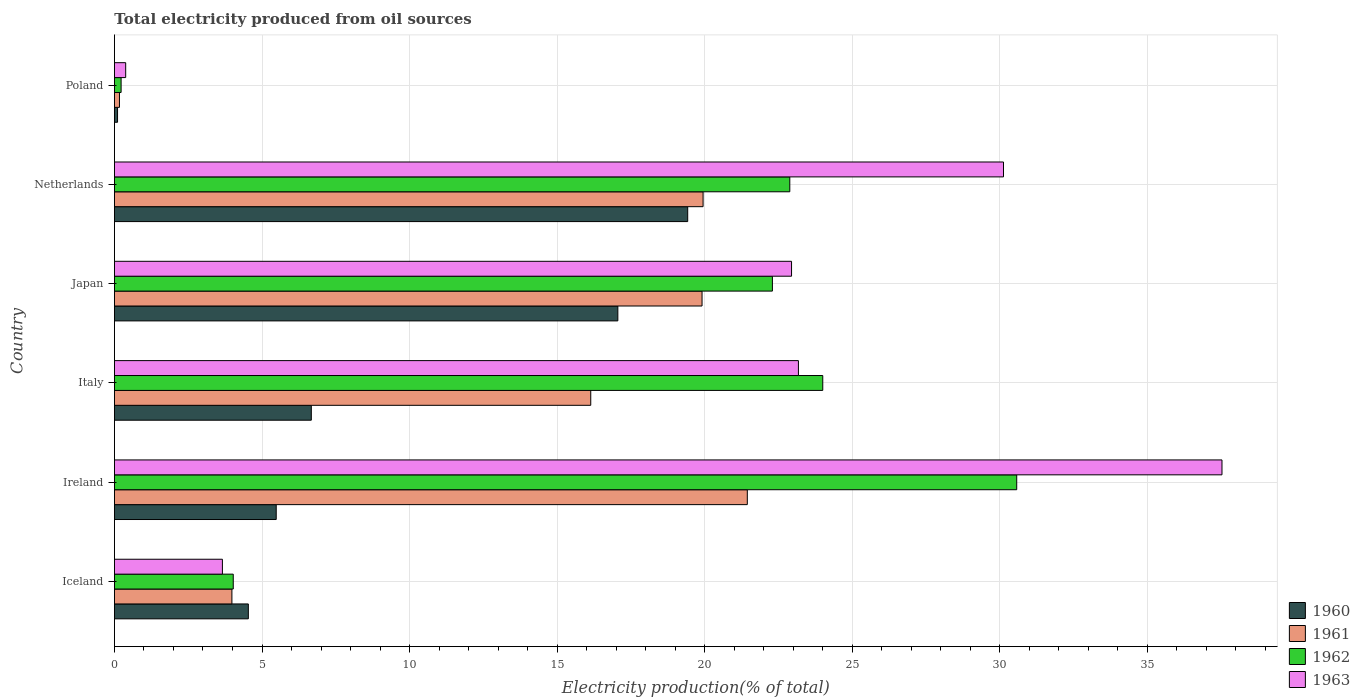How many different coloured bars are there?
Your answer should be very brief. 4. How many groups of bars are there?
Your answer should be very brief. 6. Are the number of bars per tick equal to the number of legend labels?
Your answer should be compact. Yes. Are the number of bars on each tick of the Y-axis equal?
Provide a succinct answer. Yes. How many bars are there on the 3rd tick from the bottom?
Give a very brief answer. 4. What is the total electricity produced in 1962 in Italy?
Your answer should be very brief. 24. Across all countries, what is the maximum total electricity produced in 1963?
Provide a succinct answer. 37.53. Across all countries, what is the minimum total electricity produced in 1960?
Make the answer very short. 0.11. What is the total total electricity produced in 1960 in the graph?
Offer a very short reply. 53.28. What is the difference between the total electricity produced in 1962 in Japan and that in Netherlands?
Your response must be concise. -0.59. What is the difference between the total electricity produced in 1962 in Italy and the total electricity produced in 1963 in Netherlands?
Make the answer very short. -6.12. What is the average total electricity produced in 1963 per country?
Provide a short and direct response. 19.63. What is the difference between the total electricity produced in 1962 and total electricity produced in 1960 in Japan?
Ensure brevity in your answer.  5.24. In how many countries, is the total electricity produced in 1961 greater than 18 %?
Offer a very short reply. 3. What is the ratio of the total electricity produced in 1963 in Netherlands to that in Poland?
Give a very brief answer. 78.92. Is the total electricity produced in 1962 in Iceland less than that in Netherlands?
Your answer should be very brief. Yes. What is the difference between the highest and the second highest total electricity produced in 1961?
Provide a short and direct response. 1.5. What is the difference between the highest and the lowest total electricity produced in 1961?
Provide a short and direct response. 21.27. In how many countries, is the total electricity produced in 1962 greater than the average total electricity produced in 1962 taken over all countries?
Your answer should be very brief. 4. Is it the case that in every country, the sum of the total electricity produced in 1962 and total electricity produced in 1963 is greater than the sum of total electricity produced in 1961 and total electricity produced in 1960?
Provide a succinct answer. No. Are all the bars in the graph horizontal?
Make the answer very short. Yes. How many countries are there in the graph?
Your response must be concise. 6. What is the difference between two consecutive major ticks on the X-axis?
Offer a terse response. 5. Where does the legend appear in the graph?
Ensure brevity in your answer.  Bottom right. What is the title of the graph?
Keep it short and to the point. Total electricity produced from oil sources. Does "1977" appear as one of the legend labels in the graph?
Your answer should be very brief. No. What is the Electricity production(% of total) in 1960 in Iceland?
Provide a short and direct response. 4.54. What is the Electricity production(% of total) in 1961 in Iceland?
Make the answer very short. 3.98. What is the Electricity production(% of total) of 1962 in Iceland?
Ensure brevity in your answer.  4.03. What is the Electricity production(% of total) of 1963 in Iceland?
Your answer should be compact. 3.66. What is the Electricity production(% of total) in 1960 in Ireland?
Provide a short and direct response. 5.48. What is the Electricity production(% of total) in 1961 in Ireland?
Your response must be concise. 21.44. What is the Electricity production(% of total) of 1962 in Ireland?
Make the answer very short. 30.57. What is the Electricity production(% of total) in 1963 in Ireland?
Offer a very short reply. 37.53. What is the Electricity production(% of total) of 1960 in Italy?
Keep it short and to the point. 6.67. What is the Electricity production(% of total) of 1961 in Italy?
Offer a very short reply. 16.14. What is the Electricity production(% of total) of 1962 in Italy?
Ensure brevity in your answer.  24. What is the Electricity production(% of total) in 1963 in Italy?
Keep it short and to the point. 23.17. What is the Electricity production(% of total) of 1960 in Japan?
Your answer should be compact. 17.06. What is the Electricity production(% of total) of 1961 in Japan?
Your answer should be compact. 19.91. What is the Electricity production(% of total) of 1962 in Japan?
Provide a short and direct response. 22.29. What is the Electricity production(% of total) of 1963 in Japan?
Your response must be concise. 22.94. What is the Electricity production(% of total) in 1960 in Netherlands?
Provide a short and direct response. 19.42. What is the Electricity production(% of total) of 1961 in Netherlands?
Offer a terse response. 19.94. What is the Electricity production(% of total) in 1962 in Netherlands?
Your answer should be compact. 22.88. What is the Electricity production(% of total) of 1963 in Netherlands?
Give a very brief answer. 30.12. What is the Electricity production(% of total) in 1960 in Poland?
Offer a very short reply. 0.11. What is the Electricity production(% of total) of 1961 in Poland?
Offer a very short reply. 0.17. What is the Electricity production(% of total) of 1962 in Poland?
Provide a succinct answer. 0.23. What is the Electricity production(% of total) in 1963 in Poland?
Give a very brief answer. 0.38. Across all countries, what is the maximum Electricity production(% of total) in 1960?
Keep it short and to the point. 19.42. Across all countries, what is the maximum Electricity production(% of total) in 1961?
Provide a succinct answer. 21.44. Across all countries, what is the maximum Electricity production(% of total) in 1962?
Offer a terse response. 30.57. Across all countries, what is the maximum Electricity production(% of total) of 1963?
Provide a succinct answer. 37.53. Across all countries, what is the minimum Electricity production(% of total) of 1960?
Your response must be concise. 0.11. Across all countries, what is the minimum Electricity production(% of total) of 1961?
Give a very brief answer. 0.17. Across all countries, what is the minimum Electricity production(% of total) in 1962?
Ensure brevity in your answer.  0.23. Across all countries, what is the minimum Electricity production(% of total) in 1963?
Make the answer very short. 0.38. What is the total Electricity production(% of total) in 1960 in the graph?
Give a very brief answer. 53.28. What is the total Electricity production(% of total) in 1961 in the graph?
Provide a succinct answer. 81.59. What is the total Electricity production(% of total) of 1962 in the graph?
Your answer should be very brief. 104. What is the total Electricity production(% of total) of 1963 in the graph?
Ensure brevity in your answer.  117.81. What is the difference between the Electricity production(% of total) of 1960 in Iceland and that in Ireland?
Your answer should be compact. -0.94. What is the difference between the Electricity production(% of total) of 1961 in Iceland and that in Ireland?
Your answer should be very brief. -17.46. What is the difference between the Electricity production(% of total) in 1962 in Iceland and that in Ireland?
Your answer should be compact. -26.55. What is the difference between the Electricity production(% of total) in 1963 in Iceland and that in Ireland?
Ensure brevity in your answer.  -33.87. What is the difference between the Electricity production(% of total) in 1960 in Iceland and that in Italy?
Offer a very short reply. -2.13. What is the difference between the Electricity production(% of total) of 1961 in Iceland and that in Italy?
Your answer should be very brief. -12.16. What is the difference between the Electricity production(% of total) of 1962 in Iceland and that in Italy?
Your response must be concise. -19.97. What is the difference between the Electricity production(% of total) in 1963 in Iceland and that in Italy?
Your response must be concise. -19.52. What is the difference between the Electricity production(% of total) of 1960 in Iceland and that in Japan?
Give a very brief answer. -12.52. What is the difference between the Electricity production(% of total) of 1961 in Iceland and that in Japan?
Give a very brief answer. -15.93. What is the difference between the Electricity production(% of total) of 1962 in Iceland and that in Japan?
Your answer should be very brief. -18.27. What is the difference between the Electricity production(% of total) in 1963 in Iceland and that in Japan?
Ensure brevity in your answer.  -19.28. What is the difference between the Electricity production(% of total) of 1960 in Iceland and that in Netherlands?
Make the answer very short. -14.89. What is the difference between the Electricity production(% of total) in 1961 in Iceland and that in Netherlands?
Provide a succinct answer. -15.96. What is the difference between the Electricity production(% of total) of 1962 in Iceland and that in Netherlands?
Provide a short and direct response. -18.86. What is the difference between the Electricity production(% of total) in 1963 in Iceland and that in Netherlands?
Provide a succinct answer. -26.46. What is the difference between the Electricity production(% of total) of 1960 in Iceland and that in Poland?
Provide a short and direct response. 4.43. What is the difference between the Electricity production(% of total) of 1961 in Iceland and that in Poland?
Make the answer very short. 3.81. What is the difference between the Electricity production(% of total) in 1962 in Iceland and that in Poland?
Keep it short and to the point. 3.8. What is the difference between the Electricity production(% of total) of 1963 in Iceland and that in Poland?
Make the answer very short. 3.28. What is the difference between the Electricity production(% of total) of 1960 in Ireland and that in Italy?
Provide a short and direct response. -1.19. What is the difference between the Electricity production(% of total) of 1961 in Ireland and that in Italy?
Offer a terse response. 5.3. What is the difference between the Electricity production(% of total) in 1962 in Ireland and that in Italy?
Make the answer very short. 6.57. What is the difference between the Electricity production(% of total) in 1963 in Ireland and that in Italy?
Provide a succinct answer. 14.35. What is the difference between the Electricity production(% of total) in 1960 in Ireland and that in Japan?
Make the answer very short. -11.57. What is the difference between the Electricity production(% of total) of 1961 in Ireland and that in Japan?
Make the answer very short. 1.53. What is the difference between the Electricity production(% of total) of 1962 in Ireland and that in Japan?
Provide a succinct answer. 8.28. What is the difference between the Electricity production(% of total) in 1963 in Ireland and that in Japan?
Keep it short and to the point. 14.58. What is the difference between the Electricity production(% of total) in 1960 in Ireland and that in Netherlands?
Make the answer very short. -13.94. What is the difference between the Electricity production(% of total) in 1961 in Ireland and that in Netherlands?
Your answer should be compact. 1.5. What is the difference between the Electricity production(% of total) of 1962 in Ireland and that in Netherlands?
Provide a succinct answer. 7.69. What is the difference between the Electricity production(% of total) in 1963 in Ireland and that in Netherlands?
Give a very brief answer. 7.4. What is the difference between the Electricity production(% of total) of 1960 in Ireland and that in Poland?
Offer a terse response. 5.38. What is the difference between the Electricity production(% of total) of 1961 in Ireland and that in Poland?
Ensure brevity in your answer.  21.27. What is the difference between the Electricity production(% of total) in 1962 in Ireland and that in Poland?
Your response must be concise. 30.34. What is the difference between the Electricity production(% of total) in 1963 in Ireland and that in Poland?
Your response must be concise. 37.14. What is the difference between the Electricity production(% of total) in 1960 in Italy and that in Japan?
Make the answer very short. -10.39. What is the difference between the Electricity production(% of total) in 1961 in Italy and that in Japan?
Make the answer very short. -3.77. What is the difference between the Electricity production(% of total) of 1962 in Italy and that in Japan?
Provide a succinct answer. 1.71. What is the difference between the Electricity production(% of total) in 1963 in Italy and that in Japan?
Make the answer very short. 0.23. What is the difference between the Electricity production(% of total) of 1960 in Italy and that in Netherlands?
Your answer should be compact. -12.75. What is the difference between the Electricity production(% of total) of 1961 in Italy and that in Netherlands?
Your response must be concise. -3.81. What is the difference between the Electricity production(% of total) of 1962 in Italy and that in Netherlands?
Offer a terse response. 1.12. What is the difference between the Electricity production(% of total) of 1963 in Italy and that in Netherlands?
Offer a very short reply. -6.95. What is the difference between the Electricity production(% of total) in 1960 in Italy and that in Poland?
Your answer should be compact. 6.57. What is the difference between the Electricity production(% of total) of 1961 in Italy and that in Poland?
Offer a very short reply. 15.97. What is the difference between the Electricity production(% of total) in 1962 in Italy and that in Poland?
Your answer should be very brief. 23.77. What is the difference between the Electricity production(% of total) in 1963 in Italy and that in Poland?
Your answer should be very brief. 22.79. What is the difference between the Electricity production(% of total) of 1960 in Japan and that in Netherlands?
Provide a short and direct response. -2.37. What is the difference between the Electricity production(% of total) in 1961 in Japan and that in Netherlands?
Keep it short and to the point. -0.04. What is the difference between the Electricity production(% of total) of 1962 in Japan and that in Netherlands?
Offer a very short reply. -0.59. What is the difference between the Electricity production(% of total) of 1963 in Japan and that in Netherlands?
Your answer should be very brief. -7.18. What is the difference between the Electricity production(% of total) of 1960 in Japan and that in Poland?
Provide a succinct answer. 16.95. What is the difference between the Electricity production(% of total) in 1961 in Japan and that in Poland?
Ensure brevity in your answer.  19.74. What is the difference between the Electricity production(% of total) in 1962 in Japan and that in Poland?
Provide a succinct answer. 22.07. What is the difference between the Electricity production(% of total) in 1963 in Japan and that in Poland?
Your answer should be compact. 22.56. What is the difference between the Electricity production(% of total) of 1960 in Netherlands and that in Poland?
Ensure brevity in your answer.  19.32. What is the difference between the Electricity production(% of total) of 1961 in Netherlands and that in Poland?
Your response must be concise. 19.77. What is the difference between the Electricity production(% of total) in 1962 in Netherlands and that in Poland?
Provide a short and direct response. 22.66. What is the difference between the Electricity production(% of total) of 1963 in Netherlands and that in Poland?
Make the answer very short. 29.74. What is the difference between the Electricity production(% of total) of 1960 in Iceland and the Electricity production(% of total) of 1961 in Ireland?
Provide a succinct answer. -16.91. What is the difference between the Electricity production(% of total) of 1960 in Iceland and the Electricity production(% of total) of 1962 in Ireland?
Make the answer very short. -26.03. What is the difference between the Electricity production(% of total) of 1960 in Iceland and the Electricity production(% of total) of 1963 in Ireland?
Your response must be concise. -32.99. What is the difference between the Electricity production(% of total) in 1961 in Iceland and the Electricity production(% of total) in 1962 in Ireland?
Ensure brevity in your answer.  -26.59. What is the difference between the Electricity production(% of total) in 1961 in Iceland and the Electricity production(% of total) in 1963 in Ireland?
Your answer should be very brief. -33.55. What is the difference between the Electricity production(% of total) of 1962 in Iceland and the Electricity production(% of total) of 1963 in Ireland?
Offer a terse response. -33.5. What is the difference between the Electricity production(% of total) of 1960 in Iceland and the Electricity production(% of total) of 1961 in Italy?
Your response must be concise. -11.6. What is the difference between the Electricity production(% of total) of 1960 in Iceland and the Electricity production(% of total) of 1962 in Italy?
Ensure brevity in your answer.  -19.46. What is the difference between the Electricity production(% of total) of 1960 in Iceland and the Electricity production(% of total) of 1963 in Italy?
Provide a short and direct response. -18.64. What is the difference between the Electricity production(% of total) in 1961 in Iceland and the Electricity production(% of total) in 1962 in Italy?
Make the answer very short. -20.02. What is the difference between the Electricity production(% of total) in 1961 in Iceland and the Electricity production(% of total) in 1963 in Italy?
Your response must be concise. -19.19. What is the difference between the Electricity production(% of total) of 1962 in Iceland and the Electricity production(% of total) of 1963 in Italy?
Your answer should be compact. -19.15. What is the difference between the Electricity production(% of total) in 1960 in Iceland and the Electricity production(% of total) in 1961 in Japan?
Make the answer very short. -15.37. What is the difference between the Electricity production(% of total) of 1960 in Iceland and the Electricity production(% of total) of 1962 in Japan?
Offer a very short reply. -17.76. What is the difference between the Electricity production(% of total) of 1960 in Iceland and the Electricity production(% of total) of 1963 in Japan?
Give a very brief answer. -18.4. What is the difference between the Electricity production(% of total) of 1961 in Iceland and the Electricity production(% of total) of 1962 in Japan?
Provide a short and direct response. -18.31. What is the difference between the Electricity production(% of total) in 1961 in Iceland and the Electricity production(% of total) in 1963 in Japan?
Give a very brief answer. -18.96. What is the difference between the Electricity production(% of total) in 1962 in Iceland and the Electricity production(% of total) in 1963 in Japan?
Provide a succinct answer. -18.92. What is the difference between the Electricity production(% of total) of 1960 in Iceland and the Electricity production(% of total) of 1961 in Netherlands?
Your answer should be compact. -15.41. What is the difference between the Electricity production(% of total) of 1960 in Iceland and the Electricity production(% of total) of 1962 in Netherlands?
Your answer should be very brief. -18.35. What is the difference between the Electricity production(% of total) in 1960 in Iceland and the Electricity production(% of total) in 1963 in Netherlands?
Offer a very short reply. -25.59. What is the difference between the Electricity production(% of total) of 1961 in Iceland and the Electricity production(% of total) of 1962 in Netherlands?
Your answer should be compact. -18.9. What is the difference between the Electricity production(% of total) of 1961 in Iceland and the Electricity production(% of total) of 1963 in Netherlands?
Your answer should be compact. -26.14. What is the difference between the Electricity production(% of total) in 1962 in Iceland and the Electricity production(% of total) in 1963 in Netherlands?
Provide a succinct answer. -26.1. What is the difference between the Electricity production(% of total) in 1960 in Iceland and the Electricity production(% of total) in 1961 in Poland?
Keep it short and to the point. 4.37. What is the difference between the Electricity production(% of total) of 1960 in Iceland and the Electricity production(% of total) of 1962 in Poland?
Keep it short and to the point. 4.31. What is the difference between the Electricity production(% of total) in 1960 in Iceland and the Electricity production(% of total) in 1963 in Poland?
Offer a very short reply. 4.16. What is the difference between the Electricity production(% of total) in 1961 in Iceland and the Electricity production(% of total) in 1962 in Poland?
Keep it short and to the point. 3.75. What is the difference between the Electricity production(% of total) of 1961 in Iceland and the Electricity production(% of total) of 1963 in Poland?
Offer a very short reply. 3.6. What is the difference between the Electricity production(% of total) in 1962 in Iceland and the Electricity production(% of total) in 1963 in Poland?
Provide a short and direct response. 3.64. What is the difference between the Electricity production(% of total) of 1960 in Ireland and the Electricity production(% of total) of 1961 in Italy?
Offer a very short reply. -10.66. What is the difference between the Electricity production(% of total) in 1960 in Ireland and the Electricity production(% of total) in 1962 in Italy?
Give a very brief answer. -18.52. What is the difference between the Electricity production(% of total) in 1960 in Ireland and the Electricity production(% of total) in 1963 in Italy?
Offer a very short reply. -17.69. What is the difference between the Electricity production(% of total) of 1961 in Ireland and the Electricity production(% of total) of 1962 in Italy?
Offer a very short reply. -2.56. What is the difference between the Electricity production(% of total) in 1961 in Ireland and the Electricity production(% of total) in 1963 in Italy?
Your answer should be compact. -1.73. What is the difference between the Electricity production(% of total) of 1962 in Ireland and the Electricity production(% of total) of 1963 in Italy?
Provide a short and direct response. 7.4. What is the difference between the Electricity production(% of total) of 1960 in Ireland and the Electricity production(% of total) of 1961 in Japan?
Provide a succinct answer. -14.43. What is the difference between the Electricity production(% of total) of 1960 in Ireland and the Electricity production(% of total) of 1962 in Japan?
Make the answer very short. -16.81. What is the difference between the Electricity production(% of total) in 1960 in Ireland and the Electricity production(% of total) in 1963 in Japan?
Keep it short and to the point. -17.46. What is the difference between the Electricity production(% of total) in 1961 in Ireland and the Electricity production(% of total) in 1962 in Japan?
Your answer should be very brief. -0.85. What is the difference between the Electricity production(% of total) of 1961 in Ireland and the Electricity production(% of total) of 1963 in Japan?
Make the answer very short. -1.5. What is the difference between the Electricity production(% of total) in 1962 in Ireland and the Electricity production(% of total) in 1963 in Japan?
Ensure brevity in your answer.  7.63. What is the difference between the Electricity production(% of total) of 1960 in Ireland and the Electricity production(% of total) of 1961 in Netherlands?
Make the answer very short. -14.46. What is the difference between the Electricity production(% of total) of 1960 in Ireland and the Electricity production(% of total) of 1962 in Netherlands?
Provide a short and direct response. -17.4. What is the difference between the Electricity production(% of total) of 1960 in Ireland and the Electricity production(% of total) of 1963 in Netherlands?
Provide a succinct answer. -24.64. What is the difference between the Electricity production(% of total) of 1961 in Ireland and the Electricity production(% of total) of 1962 in Netherlands?
Make the answer very short. -1.44. What is the difference between the Electricity production(% of total) in 1961 in Ireland and the Electricity production(% of total) in 1963 in Netherlands?
Provide a short and direct response. -8.68. What is the difference between the Electricity production(% of total) of 1962 in Ireland and the Electricity production(% of total) of 1963 in Netherlands?
Make the answer very short. 0.45. What is the difference between the Electricity production(% of total) of 1960 in Ireland and the Electricity production(% of total) of 1961 in Poland?
Offer a very short reply. 5.31. What is the difference between the Electricity production(% of total) of 1960 in Ireland and the Electricity production(% of total) of 1962 in Poland?
Your answer should be very brief. 5.26. What is the difference between the Electricity production(% of total) of 1960 in Ireland and the Electricity production(% of total) of 1963 in Poland?
Offer a very short reply. 5.1. What is the difference between the Electricity production(% of total) of 1961 in Ireland and the Electricity production(% of total) of 1962 in Poland?
Your response must be concise. 21.22. What is the difference between the Electricity production(% of total) of 1961 in Ireland and the Electricity production(% of total) of 1963 in Poland?
Give a very brief answer. 21.06. What is the difference between the Electricity production(% of total) of 1962 in Ireland and the Electricity production(% of total) of 1963 in Poland?
Provide a short and direct response. 30.19. What is the difference between the Electricity production(% of total) in 1960 in Italy and the Electricity production(% of total) in 1961 in Japan?
Make the answer very short. -13.24. What is the difference between the Electricity production(% of total) of 1960 in Italy and the Electricity production(% of total) of 1962 in Japan?
Offer a terse response. -15.62. What is the difference between the Electricity production(% of total) in 1960 in Italy and the Electricity production(% of total) in 1963 in Japan?
Keep it short and to the point. -16.27. What is the difference between the Electricity production(% of total) of 1961 in Italy and the Electricity production(% of total) of 1962 in Japan?
Make the answer very short. -6.15. What is the difference between the Electricity production(% of total) in 1961 in Italy and the Electricity production(% of total) in 1963 in Japan?
Ensure brevity in your answer.  -6.8. What is the difference between the Electricity production(% of total) of 1962 in Italy and the Electricity production(% of total) of 1963 in Japan?
Offer a very short reply. 1.06. What is the difference between the Electricity production(% of total) of 1960 in Italy and the Electricity production(% of total) of 1961 in Netherlands?
Your answer should be compact. -13.27. What is the difference between the Electricity production(% of total) in 1960 in Italy and the Electricity production(% of total) in 1962 in Netherlands?
Offer a very short reply. -16.21. What is the difference between the Electricity production(% of total) of 1960 in Italy and the Electricity production(% of total) of 1963 in Netherlands?
Your answer should be compact. -23.45. What is the difference between the Electricity production(% of total) of 1961 in Italy and the Electricity production(% of total) of 1962 in Netherlands?
Ensure brevity in your answer.  -6.74. What is the difference between the Electricity production(% of total) in 1961 in Italy and the Electricity production(% of total) in 1963 in Netherlands?
Provide a short and direct response. -13.98. What is the difference between the Electricity production(% of total) in 1962 in Italy and the Electricity production(% of total) in 1963 in Netherlands?
Your response must be concise. -6.12. What is the difference between the Electricity production(% of total) in 1960 in Italy and the Electricity production(% of total) in 1961 in Poland?
Provide a succinct answer. 6.5. What is the difference between the Electricity production(% of total) in 1960 in Italy and the Electricity production(% of total) in 1962 in Poland?
Ensure brevity in your answer.  6.44. What is the difference between the Electricity production(% of total) in 1960 in Italy and the Electricity production(% of total) in 1963 in Poland?
Keep it short and to the point. 6.29. What is the difference between the Electricity production(% of total) of 1961 in Italy and the Electricity production(% of total) of 1962 in Poland?
Offer a terse response. 15.91. What is the difference between the Electricity production(% of total) of 1961 in Italy and the Electricity production(% of total) of 1963 in Poland?
Provide a short and direct response. 15.76. What is the difference between the Electricity production(% of total) in 1962 in Italy and the Electricity production(% of total) in 1963 in Poland?
Keep it short and to the point. 23.62. What is the difference between the Electricity production(% of total) of 1960 in Japan and the Electricity production(% of total) of 1961 in Netherlands?
Give a very brief answer. -2.89. What is the difference between the Electricity production(% of total) in 1960 in Japan and the Electricity production(% of total) in 1962 in Netherlands?
Give a very brief answer. -5.83. What is the difference between the Electricity production(% of total) of 1960 in Japan and the Electricity production(% of total) of 1963 in Netherlands?
Offer a very short reply. -13.07. What is the difference between the Electricity production(% of total) of 1961 in Japan and the Electricity production(% of total) of 1962 in Netherlands?
Make the answer very short. -2.97. What is the difference between the Electricity production(% of total) in 1961 in Japan and the Electricity production(% of total) in 1963 in Netherlands?
Provide a succinct answer. -10.21. What is the difference between the Electricity production(% of total) in 1962 in Japan and the Electricity production(% of total) in 1963 in Netherlands?
Make the answer very short. -7.83. What is the difference between the Electricity production(% of total) of 1960 in Japan and the Electricity production(% of total) of 1961 in Poland?
Your answer should be compact. 16.89. What is the difference between the Electricity production(% of total) in 1960 in Japan and the Electricity production(% of total) in 1962 in Poland?
Give a very brief answer. 16.83. What is the difference between the Electricity production(% of total) of 1960 in Japan and the Electricity production(% of total) of 1963 in Poland?
Your answer should be very brief. 16.67. What is the difference between the Electricity production(% of total) of 1961 in Japan and the Electricity production(% of total) of 1962 in Poland?
Your answer should be compact. 19.68. What is the difference between the Electricity production(% of total) in 1961 in Japan and the Electricity production(% of total) in 1963 in Poland?
Provide a short and direct response. 19.53. What is the difference between the Electricity production(% of total) in 1962 in Japan and the Electricity production(% of total) in 1963 in Poland?
Provide a short and direct response. 21.91. What is the difference between the Electricity production(% of total) of 1960 in Netherlands and the Electricity production(% of total) of 1961 in Poland?
Keep it short and to the point. 19.25. What is the difference between the Electricity production(% of total) in 1960 in Netherlands and the Electricity production(% of total) in 1962 in Poland?
Give a very brief answer. 19.2. What is the difference between the Electricity production(% of total) of 1960 in Netherlands and the Electricity production(% of total) of 1963 in Poland?
Your answer should be compact. 19.04. What is the difference between the Electricity production(% of total) of 1961 in Netherlands and the Electricity production(% of total) of 1962 in Poland?
Your answer should be compact. 19.72. What is the difference between the Electricity production(% of total) in 1961 in Netherlands and the Electricity production(% of total) in 1963 in Poland?
Your response must be concise. 19.56. What is the difference between the Electricity production(% of total) in 1962 in Netherlands and the Electricity production(% of total) in 1963 in Poland?
Provide a short and direct response. 22.5. What is the average Electricity production(% of total) in 1960 per country?
Make the answer very short. 8.88. What is the average Electricity production(% of total) in 1961 per country?
Keep it short and to the point. 13.6. What is the average Electricity production(% of total) in 1962 per country?
Keep it short and to the point. 17.33. What is the average Electricity production(% of total) of 1963 per country?
Your response must be concise. 19.63. What is the difference between the Electricity production(% of total) in 1960 and Electricity production(% of total) in 1961 in Iceland?
Your response must be concise. 0.56. What is the difference between the Electricity production(% of total) in 1960 and Electricity production(% of total) in 1962 in Iceland?
Provide a short and direct response. 0.51. What is the difference between the Electricity production(% of total) of 1960 and Electricity production(% of total) of 1963 in Iceland?
Make the answer very short. 0.88. What is the difference between the Electricity production(% of total) of 1961 and Electricity production(% of total) of 1962 in Iceland?
Offer a terse response. -0.05. What is the difference between the Electricity production(% of total) in 1961 and Electricity production(% of total) in 1963 in Iceland?
Provide a succinct answer. 0.32. What is the difference between the Electricity production(% of total) in 1962 and Electricity production(% of total) in 1963 in Iceland?
Keep it short and to the point. 0.37. What is the difference between the Electricity production(% of total) of 1960 and Electricity production(% of total) of 1961 in Ireland?
Give a very brief answer. -15.96. What is the difference between the Electricity production(% of total) of 1960 and Electricity production(% of total) of 1962 in Ireland?
Your answer should be compact. -25.09. What is the difference between the Electricity production(% of total) of 1960 and Electricity production(% of total) of 1963 in Ireland?
Your answer should be compact. -32.04. What is the difference between the Electricity production(% of total) of 1961 and Electricity production(% of total) of 1962 in Ireland?
Your response must be concise. -9.13. What is the difference between the Electricity production(% of total) of 1961 and Electricity production(% of total) of 1963 in Ireland?
Your response must be concise. -16.08. What is the difference between the Electricity production(% of total) in 1962 and Electricity production(% of total) in 1963 in Ireland?
Make the answer very short. -6.95. What is the difference between the Electricity production(% of total) in 1960 and Electricity production(% of total) in 1961 in Italy?
Ensure brevity in your answer.  -9.47. What is the difference between the Electricity production(% of total) in 1960 and Electricity production(% of total) in 1962 in Italy?
Your answer should be compact. -17.33. What is the difference between the Electricity production(% of total) in 1960 and Electricity production(% of total) in 1963 in Italy?
Keep it short and to the point. -16.5. What is the difference between the Electricity production(% of total) in 1961 and Electricity production(% of total) in 1962 in Italy?
Make the answer very short. -7.86. What is the difference between the Electricity production(% of total) of 1961 and Electricity production(% of total) of 1963 in Italy?
Offer a very short reply. -7.04. What is the difference between the Electricity production(% of total) of 1962 and Electricity production(% of total) of 1963 in Italy?
Offer a terse response. 0.83. What is the difference between the Electricity production(% of total) of 1960 and Electricity production(% of total) of 1961 in Japan?
Provide a succinct answer. -2.85. What is the difference between the Electricity production(% of total) of 1960 and Electricity production(% of total) of 1962 in Japan?
Make the answer very short. -5.24. What is the difference between the Electricity production(% of total) of 1960 and Electricity production(% of total) of 1963 in Japan?
Your answer should be very brief. -5.89. What is the difference between the Electricity production(% of total) in 1961 and Electricity production(% of total) in 1962 in Japan?
Your response must be concise. -2.38. What is the difference between the Electricity production(% of total) of 1961 and Electricity production(% of total) of 1963 in Japan?
Ensure brevity in your answer.  -3.03. What is the difference between the Electricity production(% of total) of 1962 and Electricity production(% of total) of 1963 in Japan?
Make the answer very short. -0.65. What is the difference between the Electricity production(% of total) of 1960 and Electricity production(% of total) of 1961 in Netherlands?
Your response must be concise. -0.52. What is the difference between the Electricity production(% of total) in 1960 and Electricity production(% of total) in 1962 in Netherlands?
Make the answer very short. -3.46. What is the difference between the Electricity production(% of total) of 1960 and Electricity production(% of total) of 1963 in Netherlands?
Provide a short and direct response. -10.7. What is the difference between the Electricity production(% of total) of 1961 and Electricity production(% of total) of 1962 in Netherlands?
Make the answer very short. -2.94. What is the difference between the Electricity production(% of total) in 1961 and Electricity production(% of total) in 1963 in Netherlands?
Offer a terse response. -10.18. What is the difference between the Electricity production(% of total) of 1962 and Electricity production(% of total) of 1963 in Netherlands?
Ensure brevity in your answer.  -7.24. What is the difference between the Electricity production(% of total) in 1960 and Electricity production(% of total) in 1961 in Poland?
Offer a terse response. -0.06. What is the difference between the Electricity production(% of total) of 1960 and Electricity production(% of total) of 1962 in Poland?
Provide a succinct answer. -0.12. What is the difference between the Electricity production(% of total) in 1960 and Electricity production(% of total) in 1963 in Poland?
Ensure brevity in your answer.  -0.28. What is the difference between the Electricity production(% of total) in 1961 and Electricity production(% of total) in 1962 in Poland?
Offer a very short reply. -0.06. What is the difference between the Electricity production(% of total) of 1961 and Electricity production(% of total) of 1963 in Poland?
Make the answer very short. -0.21. What is the difference between the Electricity production(% of total) in 1962 and Electricity production(% of total) in 1963 in Poland?
Provide a short and direct response. -0.16. What is the ratio of the Electricity production(% of total) in 1960 in Iceland to that in Ireland?
Ensure brevity in your answer.  0.83. What is the ratio of the Electricity production(% of total) in 1961 in Iceland to that in Ireland?
Your answer should be compact. 0.19. What is the ratio of the Electricity production(% of total) of 1962 in Iceland to that in Ireland?
Keep it short and to the point. 0.13. What is the ratio of the Electricity production(% of total) of 1963 in Iceland to that in Ireland?
Ensure brevity in your answer.  0.1. What is the ratio of the Electricity production(% of total) of 1960 in Iceland to that in Italy?
Your answer should be compact. 0.68. What is the ratio of the Electricity production(% of total) in 1961 in Iceland to that in Italy?
Ensure brevity in your answer.  0.25. What is the ratio of the Electricity production(% of total) of 1962 in Iceland to that in Italy?
Give a very brief answer. 0.17. What is the ratio of the Electricity production(% of total) in 1963 in Iceland to that in Italy?
Your answer should be very brief. 0.16. What is the ratio of the Electricity production(% of total) in 1960 in Iceland to that in Japan?
Your answer should be compact. 0.27. What is the ratio of the Electricity production(% of total) of 1961 in Iceland to that in Japan?
Give a very brief answer. 0.2. What is the ratio of the Electricity production(% of total) of 1962 in Iceland to that in Japan?
Provide a short and direct response. 0.18. What is the ratio of the Electricity production(% of total) in 1963 in Iceland to that in Japan?
Your response must be concise. 0.16. What is the ratio of the Electricity production(% of total) in 1960 in Iceland to that in Netherlands?
Offer a terse response. 0.23. What is the ratio of the Electricity production(% of total) in 1961 in Iceland to that in Netherlands?
Offer a terse response. 0.2. What is the ratio of the Electricity production(% of total) of 1962 in Iceland to that in Netherlands?
Provide a succinct answer. 0.18. What is the ratio of the Electricity production(% of total) in 1963 in Iceland to that in Netherlands?
Make the answer very short. 0.12. What is the ratio of the Electricity production(% of total) of 1960 in Iceland to that in Poland?
Offer a very short reply. 42.86. What is the ratio of the Electricity production(% of total) in 1961 in Iceland to that in Poland?
Offer a terse response. 23.33. What is the ratio of the Electricity production(% of total) in 1962 in Iceland to that in Poland?
Keep it short and to the point. 17.8. What is the ratio of the Electricity production(% of total) of 1963 in Iceland to that in Poland?
Make the answer very short. 9.59. What is the ratio of the Electricity production(% of total) in 1960 in Ireland to that in Italy?
Ensure brevity in your answer.  0.82. What is the ratio of the Electricity production(% of total) of 1961 in Ireland to that in Italy?
Your response must be concise. 1.33. What is the ratio of the Electricity production(% of total) of 1962 in Ireland to that in Italy?
Your answer should be very brief. 1.27. What is the ratio of the Electricity production(% of total) of 1963 in Ireland to that in Italy?
Provide a short and direct response. 1.62. What is the ratio of the Electricity production(% of total) in 1960 in Ireland to that in Japan?
Ensure brevity in your answer.  0.32. What is the ratio of the Electricity production(% of total) in 1961 in Ireland to that in Japan?
Provide a succinct answer. 1.08. What is the ratio of the Electricity production(% of total) in 1962 in Ireland to that in Japan?
Your answer should be compact. 1.37. What is the ratio of the Electricity production(% of total) in 1963 in Ireland to that in Japan?
Your response must be concise. 1.64. What is the ratio of the Electricity production(% of total) in 1960 in Ireland to that in Netherlands?
Your response must be concise. 0.28. What is the ratio of the Electricity production(% of total) in 1961 in Ireland to that in Netherlands?
Your answer should be compact. 1.08. What is the ratio of the Electricity production(% of total) in 1962 in Ireland to that in Netherlands?
Provide a short and direct response. 1.34. What is the ratio of the Electricity production(% of total) of 1963 in Ireland to that in Netherlands?
Offer a terse response. 1.25. What is the ratio of the Electricity production(% of total) in 1960 in Ireland to that in Poland?
Ensure brevity in your answer.  51.78. What is the ratio of the Electricity production(% of total) in 1961 in Ireland to that in Poland?
Offer a very short reply. 125.7. What is the ratio of the Electricity production(% of total) of 1962 in Ireland to that in Poland?
Offer a terse response. 135.14. What is the ratio of the Electricity production(% of total) of 1963 in Ireland to that in Poland?
Ensure brevity in your answer.  98.31. What is the ratio of the Electricity production(% of total) in 1960 in Italy to that in Japan?
Offer a terse response. 0.39. What is the ratio of the Electricity production(% of total) in 1961 in Italy to that in Japan?
Provide a succinct answer. 0.81. What is the ratio of the Electricity production(% of total) of 1962 in Italy to that in Japan?
Make the answer very short. 1.08. What is the ratio of the Electricity production(% of total) of 1963 in Italy to that in Japan?
Offer a terse response. 1.01. What is the ratio of the Electricity production(% of total) in 1960 in Italy to that in Netherlands?
Offer a terse response. 0.34. What is the ratio of the Electricity production(% of total) in 1961 in Italy to that in Netherlands?
Offer a terse response. 0.81. What is the ratio of the Electricity production(% of total) in 1962 in Italy to that in Netherlands?
Provide a succinct answer. 1.05. What is the ratio of the Electricity production(% of total) of 1963 in Italy to that in Netherlands?
Offer a very short reply. 0.77. What is the ratio of the Electricity production(% of total) of 1960 in Italy to that in Poland?
Ensure brevity in your answer.  63.01. What is the ratio of the Electricity production(% of total) in 1961 in Italy to that in Poland?
Your answer should be compact. 94.6. What is the ratio of the Electricity production(% of total) of 1962 in Italy to that in Poland?
Provide a short and direct response. 106.09. What is the ratio of the Electricity production(% of total) of 1963 in Italy to that in Poland?
Your response must be concise. 60.72. What is the ratio of the Electricity production(% of total) in 1960 in Japan to that in Netherlands?
Offer a terse response. 0.88. What is the ratio of the Electricity production(% of total) of 1962 in Japan to that in Netherlands?
Your answer should be compact. 0.97. What is the ratio of the Electricity production(% of total) of 1963 in Japan to that in Netherlands?
Your answer should be compact. 0.76. What is the ratio of the Electricity production(% of total) of 1960 in Japan to that in Poland?
Your answer should be very brief. 161.11. What is the ratio of the Electricity production(% of total) of 1961 in Japan to that in Poland?
Make the answer very short. 116.7. What is the ratio of the Electricity production(% of total) of 1962 in Japan to that in Poland?
Your response must be concise. 98.55. What is the ratio of the Electricity production(% of total) in 1963 in Japan to that in Poland?
Your answer should be very brief. 60.11. What is the ratio of the Electricity production(% of total) in 1960 in Netherlands to that in Poland?
Offer a very short reply. 183.47. What is the ratio of the Electricity production(% of total) in 1961 in Netherlands to that in Poland?
Provide a short and direct response. 116.91. What is the ratio of the Electricity production(% of total) of 1962 in Netherlands to that in Poland?
Keep it short and to the point. 101.15. What is the ratio of the Electricity production(% of total) of 1963 in Netherlands to that in Poland?
Offer a terse response. 78.92. What is the difference between the highest and the second highest Electricity production(% of total) in 1960?
Offer a terse response. 2.37. What is the difference between the highest and the second highest Electricity production(% of total) in 1961?
Your answer should be very brief. 1.5. What is the difference between the highest and the second highest Electricity production(% of total) in 1962?
Provide a short and direct response. 6.57. What is the difference between the highest and the second highest Electricity production(% of total) of 1963?
Keep it short and to the point. 7.4. What is the difference between the highest and the lowest Electricity production(% of total) of 1960?
Your answer should be compact. 19.32. What is the difference between the highest and the lowest Electricity production(% of total) of 1961?
Provide a succinct answer. 21.27. What is the difference between the highest and the lowest Electricity production(% of total) of 1962?
Provide a succinct answer. 30.34. What is the difference between the highest and the lowest Electricity production(% of total) in 1963?
Ensure brevity in your answer.  37.14. 